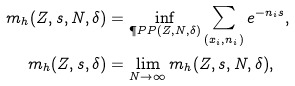Convert formula to latex. <formula><loc_0><loc_0><loc_500><loc_500>m _ { h } ( Z , s , N , \delta ) & = \inf _ { \P P P ( Z , N , \delta ) } \sum _ { ( x _ { i } , n _ { i } ) } e ^ { - n _ { i } s } , \\ m _ { h } ( Z , s , \delta ) & = \lim _ { N \to \infty } m _ { h } ( Z , s , N , \delta ) ,</formula> 